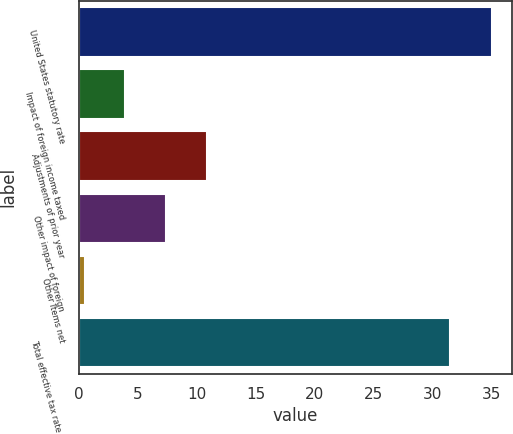Convert chart to OTSL. <chart><loc_0><loc_0><loc_500><loc_500><bar_chart><fcel>United States statutory rate<fcel>Impact of foreign income taxed<fcel>Adjustments of prior year<fcel>Other impact of foreign<fcel>Other items net<fcel>Total effective tax rate on<nl><fcel>35<fcel>3.95<fcel>10.85<fcel>7.4<fcel>0.5<fcel>31.5<nl></chart> 